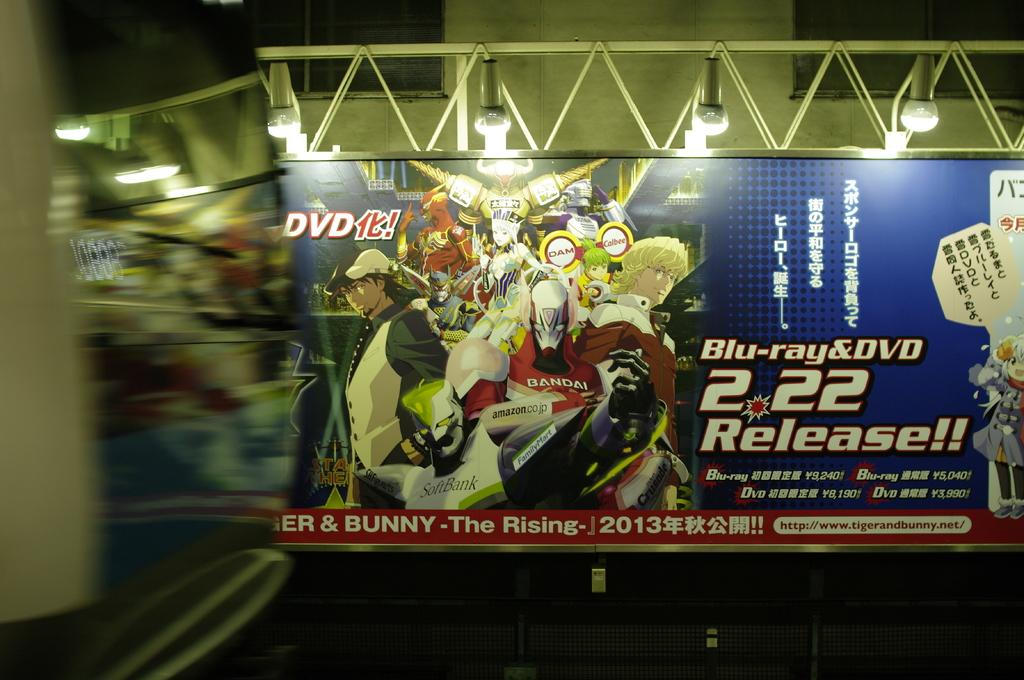<image>
Render a clear and concise summary of the photo. a comic book ad with blue-ray and DVD release 